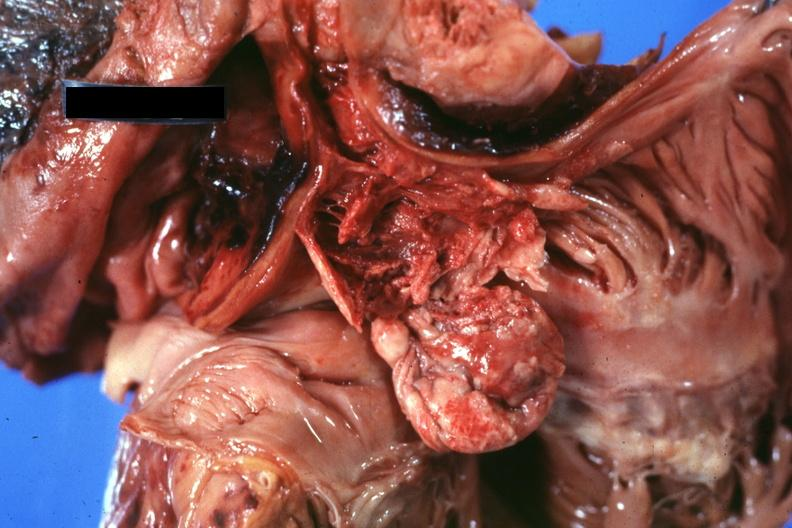s myocardium present?
Answer the question using a single word or phrase. No 